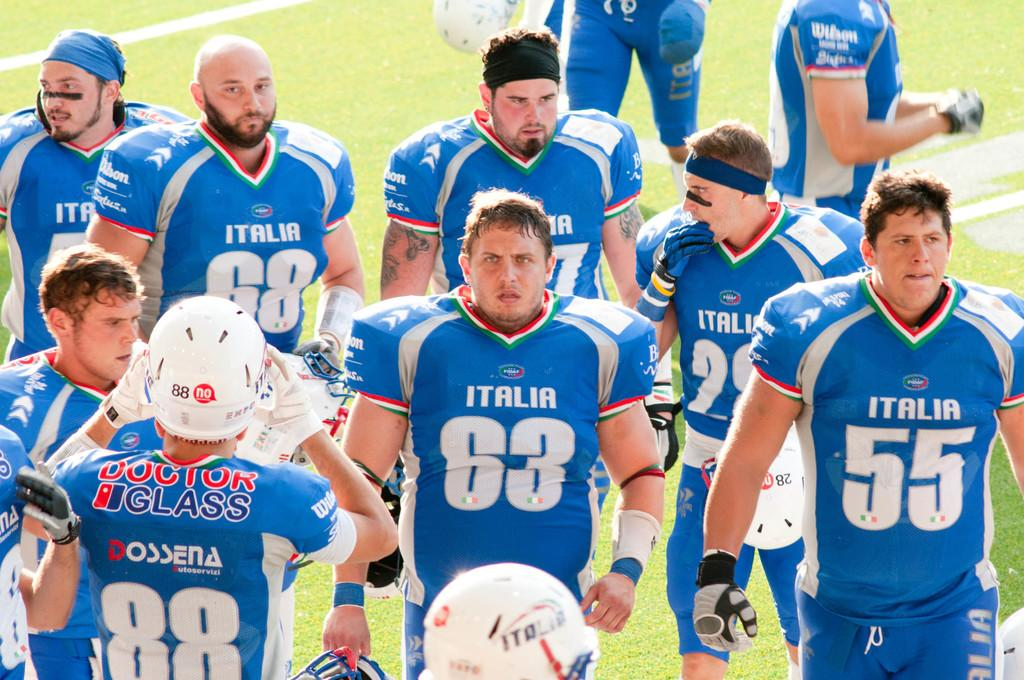<image>
Offer a succinct explanation of the picture presented. Men in Italia uniforms are standing together on a field. 